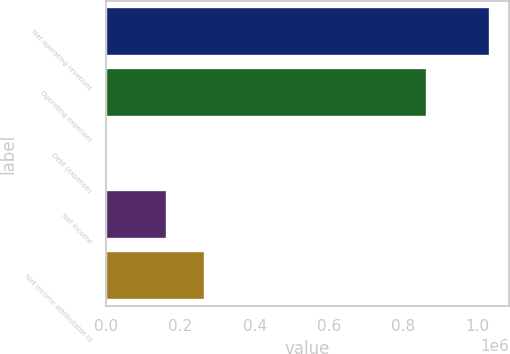<chart> <loc_0><loc_0><loc_500><loc_500><bar_chart><fcel>Net operating revenues<fcel>Operating expenses<fcel>Debt (expense)<fcel>Net income<fcel>Net income attributable to<nl><fcel>1.03268e+06<fcel>863518<fcel>1304<fcel>162845<fcel>265982<nl></chart> 